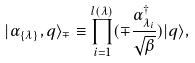Convert formula to latex. <formula><loc_0><loc_0><loc_500><loc_500>| \alpha _ { \{ \lambda \} } , q \rangle _ { \mp } \equiv \prod _ { i = 1 } ^ { l ( \lambda ) } ( \mp \frac { \alpha _ { \lambda _ { i } } ^ { \dagger } } { \sqrt { \beta } } ) | q \rangle ,</formula> 